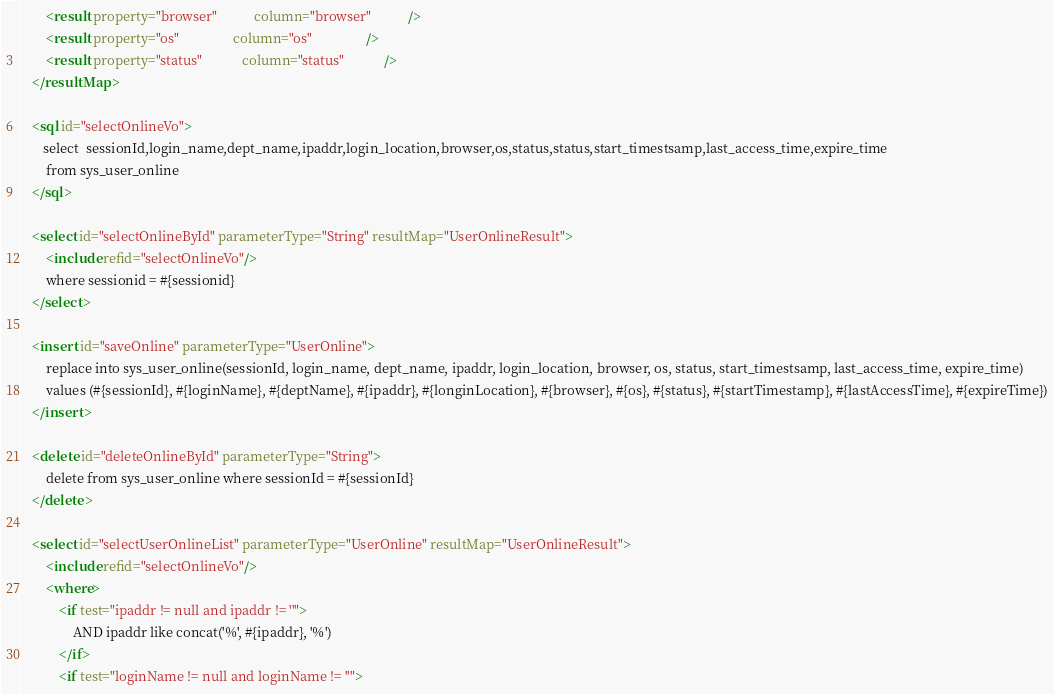<code> <loc_0><loc_0><loc_500><loc_500><_XML_>		<result property="browser"           column="browser"           />
		<result property="os"                column="os"                />
		<result property="status"            column="status"            />
	</resultMap>
	
	<sql id="selectOnlineVo">
       select  sessionId,login_name,dept_name,ipaddr,login_location,browser,os,status,status,start_timestsamp,last_access_time,expire_time
		from sys_user_online
    </sql>
    
	<select id="selectOnlineById" parameterType="String" resultMap="UserOnlineResult">
		<include refid="selectOnlineVo"/>
		where sessionid = #{sessionid}
	</select>

	<insert id="saveOnline" parameterType="UserOnline">
		replace into sys_user_online(sessionId, login_name, dept_name, ipaddr, login_location, browser, os, status, start_timestsamp, last_access_time, expire_time)
        values (#{sessionId}, #{loginName}, #{deptName}, #{ipaddr}, #{longinLocation}, #{browser}, #{os}, #{status}, #{startTimestamp}, #{lastAccessTime}, #{expireTime})
	</insert>
	
 	<delete id="deleteOnlineById" parameterType="String">
 		delete from sys_user_online where sessionId = #{sessionId}
 	</delete>
 	
 	<select id="selectUserOnlineList" parameterType="UserOnline" resultMap="UserOnlineResult">
		<include refid="selectOnlineVo"/>
		<where>
			<if test="ipaddr != null and ipaddr != ''">
				AND ipaddr like concat('%', #{ipaddr}, '%')
			</if>
			<if test="loginName != null and loginName != ''"></code> 